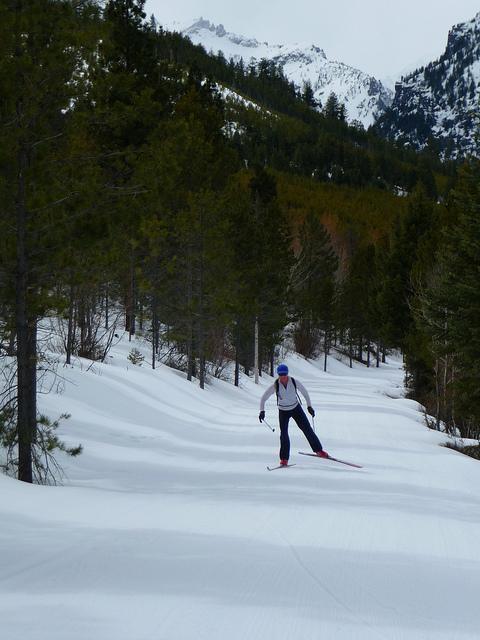How many skiers are in the photo?
Give a very brief answer. 1. How many cats are there?
Give a very brief answer. 0. 